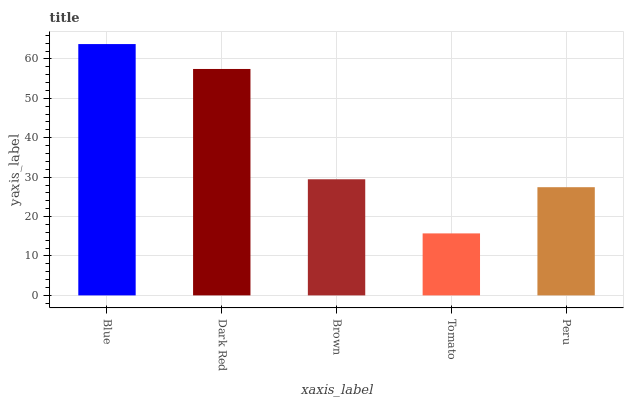Is Tomato the minimum?
Answer yes or no. Yes. Is Blue the maximum?
Answer yes or no. Yes. Is Dark Red the minimum?
Answer yes or no. No. Is Dark Red the maximum?
Answer yes or no. No. Is Blue greater than Dark Red?
Answer yes or no. Yes. Is Dark Red less than Blue?
Answer yes or no. Yes. Is Dark Red greater than Blue?
Answer yes or no. No. Is Blue less than Dark Red?
Answer yes or no. No. Is Brown the high median?
Answer yes or no. Yes. Is Brown the low median?
Answer yes or no. Yes. Is Tomato the high median?
Answer yes or no. No. Is Dark Red the low median?
Answer yes or no. No. 